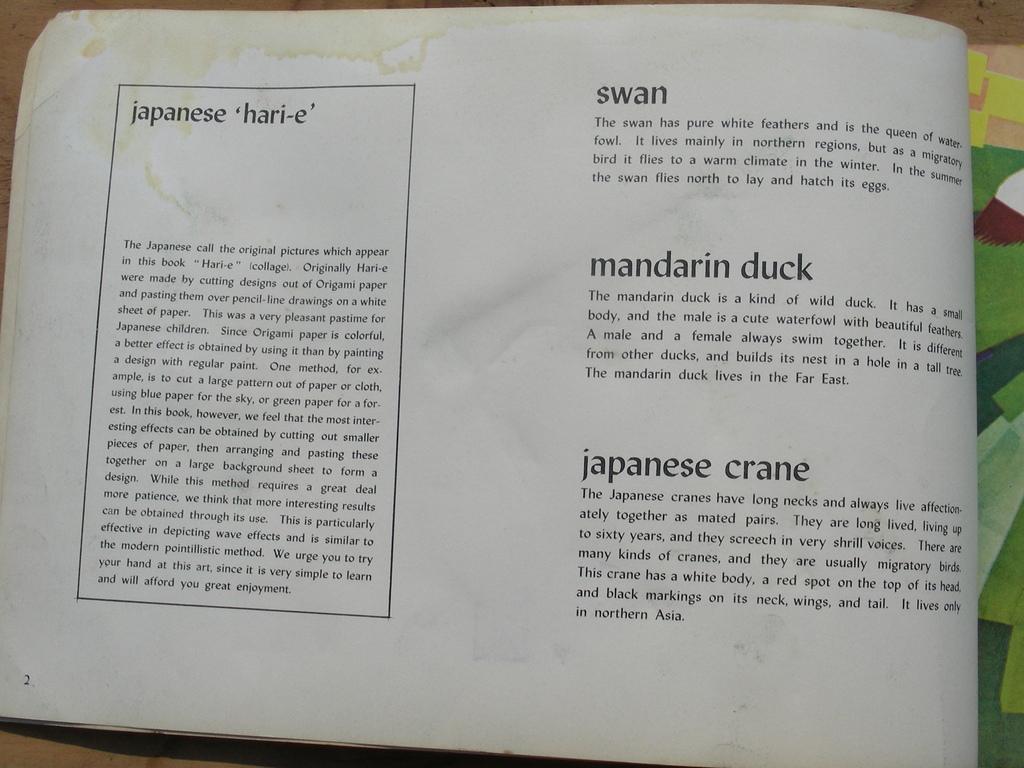Why type of duck is on the page?
Make the answer very short. Mandarin. What language do you see?
Provide a short and direct response. English. 